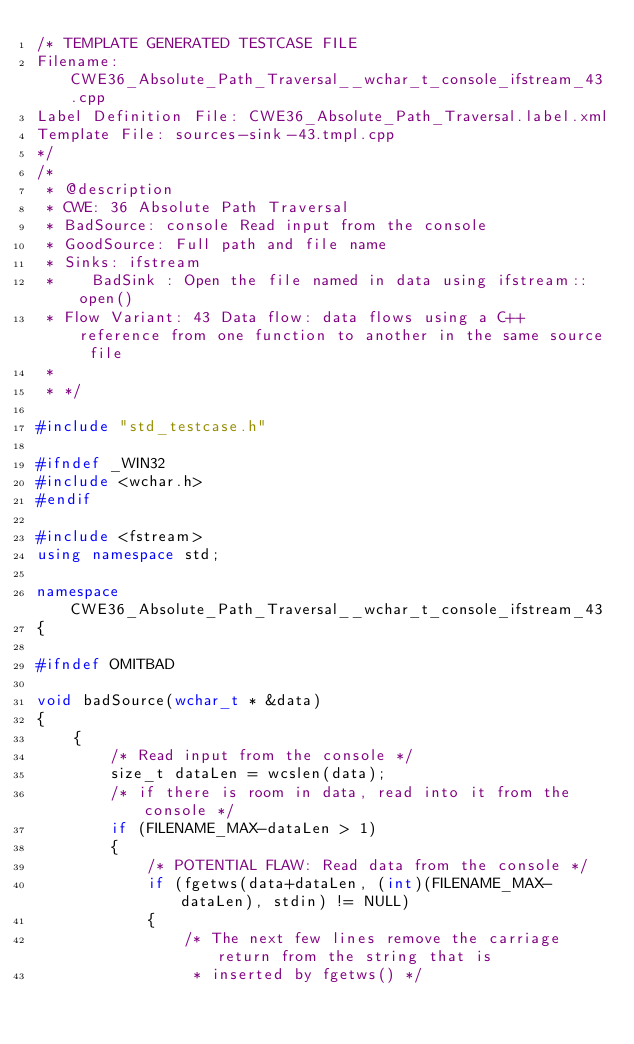<code> <loc_0><loc_0><loc_500><loc_500><_C++_>/* TEMPLATE GENERATED TESTCASE FILE
Filename: CWE36_Absolute_Path_Traversal__wchar_t_console_ifstream_43.cpp
Label Definition File: CWE36_Absolute_Path_Traversal.label.xml
Template File: sources-sink-43.tmpl.cpp
*/
/*
 * @description
 * CWE: 36 Absolute Path Traversal
 * BadSource: console Read input from the console
 * GoodSource: Full path and file name
 * Sinks: ifstream
 *    BadSink : Open the file named in data using ifstream::open()
 * Flow Variant: 43 Data flow: data flows using a C++ reference from one function to another in the same source file
 *
 * */

#include "std_testcase.h"

#ifndef _WIN32
#include <wchar.h>
#endif

#include <fstream>
using namespace std;

namespace CWE36_Absolute_Path_Traversal__wchar_t_console_ifstream_43
{

#ifndef OMITBAD

void badSource(wchar_t * &data)
{
    {
        /* Read input from the console */
        size_t dataLen = wcslen(data);
        /* if there is room in data, read into it from the console */
        if (FILENAME_MAX-dataLen > 1)
        {
            /* POTENTIAL FLAW: Read data from the console */
            if (fgetws(data+dataLen, (int)(FILENAME_MAX-dataLen), stdin) != NULL)
            {
                /* The next few lines remove the carriage return from the string that is
                 * inserted by fgetws() */</code> 